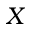<formula> <loc_0><loc_0><loc_500><loc_500>X</formula> 